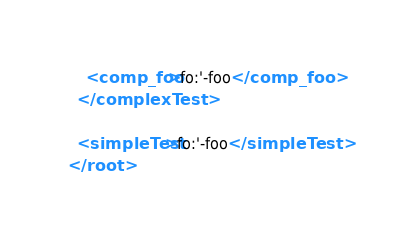Convert code to text. <code><loc_0><loc_0><loc_500><loc_500><_XML_>    <comp_foo>fo:'-foo</comp_foo>
  </complexTest>
 
  <simpleTest>fo:'-foo</simpleTest>
</root>
</code> 